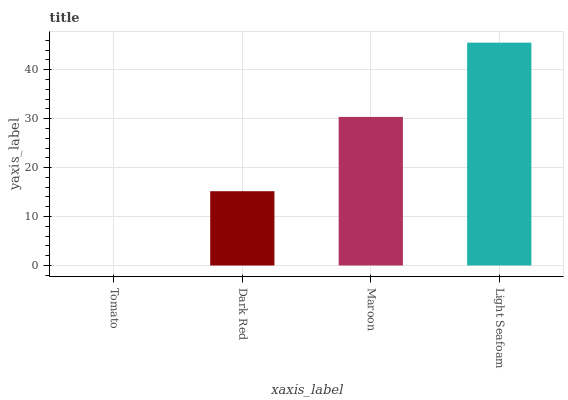Is Tomato the minimum?
Answer yes or no. Yes. Is Light Seafoam the maximum?
Answer yes or no. Yes. Is Dark Red the minimum?
Answer yes or no. No. Is Dark Red the maximum?
Answer yes or no. No. Is Dark Red greater than Tomato?
Answer yes or no. Yes. Is Tomato less than Dark Red?
Answer yes or no. Yes. Is Tomato greater than Dark Red?
Answer yes or no. No. Is Dark Red less than Tomato?
Answer yes or no. No. Is Maroon the high median?
Answer yes or no. Yes. Is Dark Red the low median?
Answer yes or no. Yes. Is Tomato the high median?
Answer yes or no. No. Is Maroon the low median?
Answer yes or no. No. 